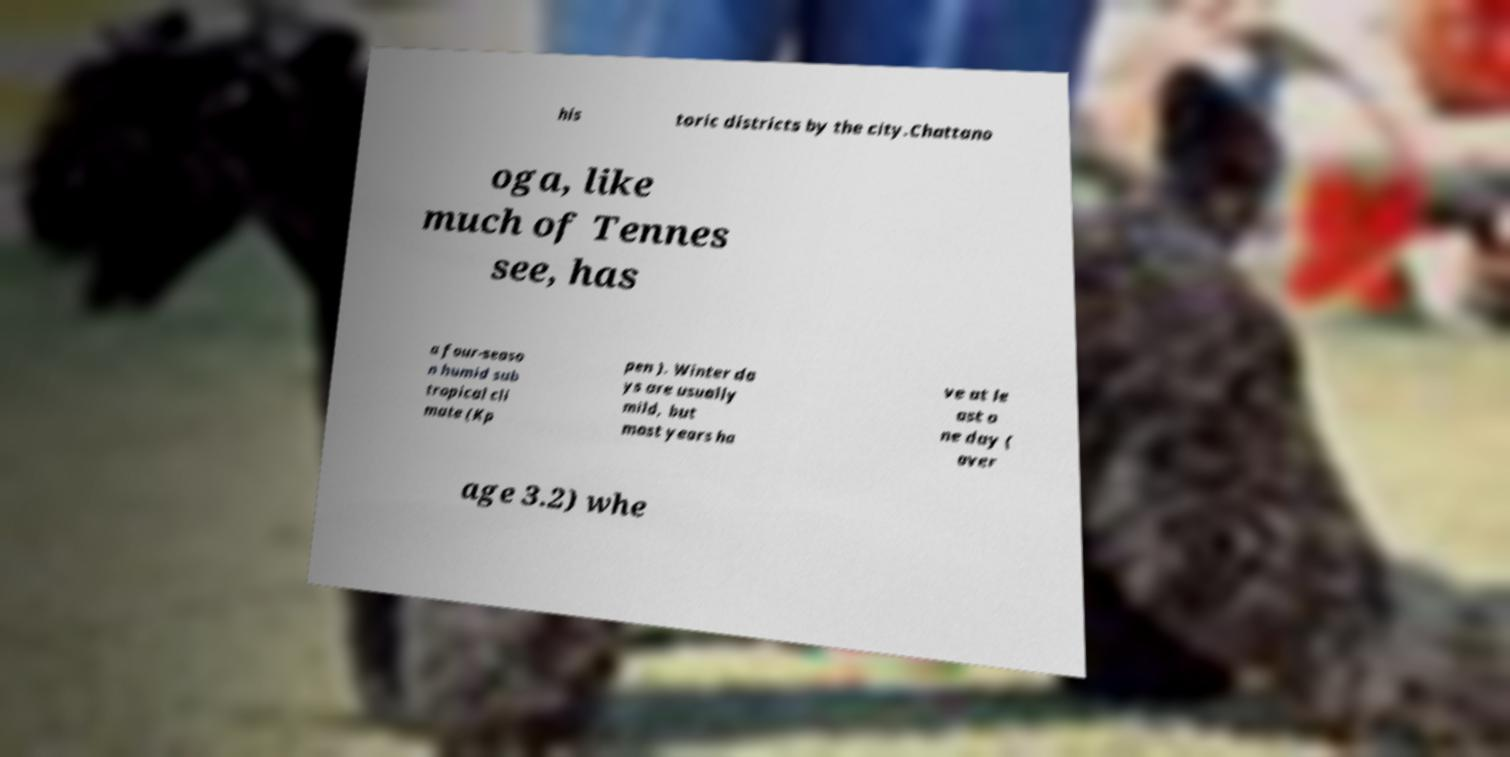Could you extract and type out the text from this image? his toric districts by the city.Chattano oga, like much of Tennes see, has a four-seaso n humid sub tropical cli mate (Kp pen ). Winter da ys are usually mild, but most years ha ve at le ast o ne day ( aver age 3.2) whe 